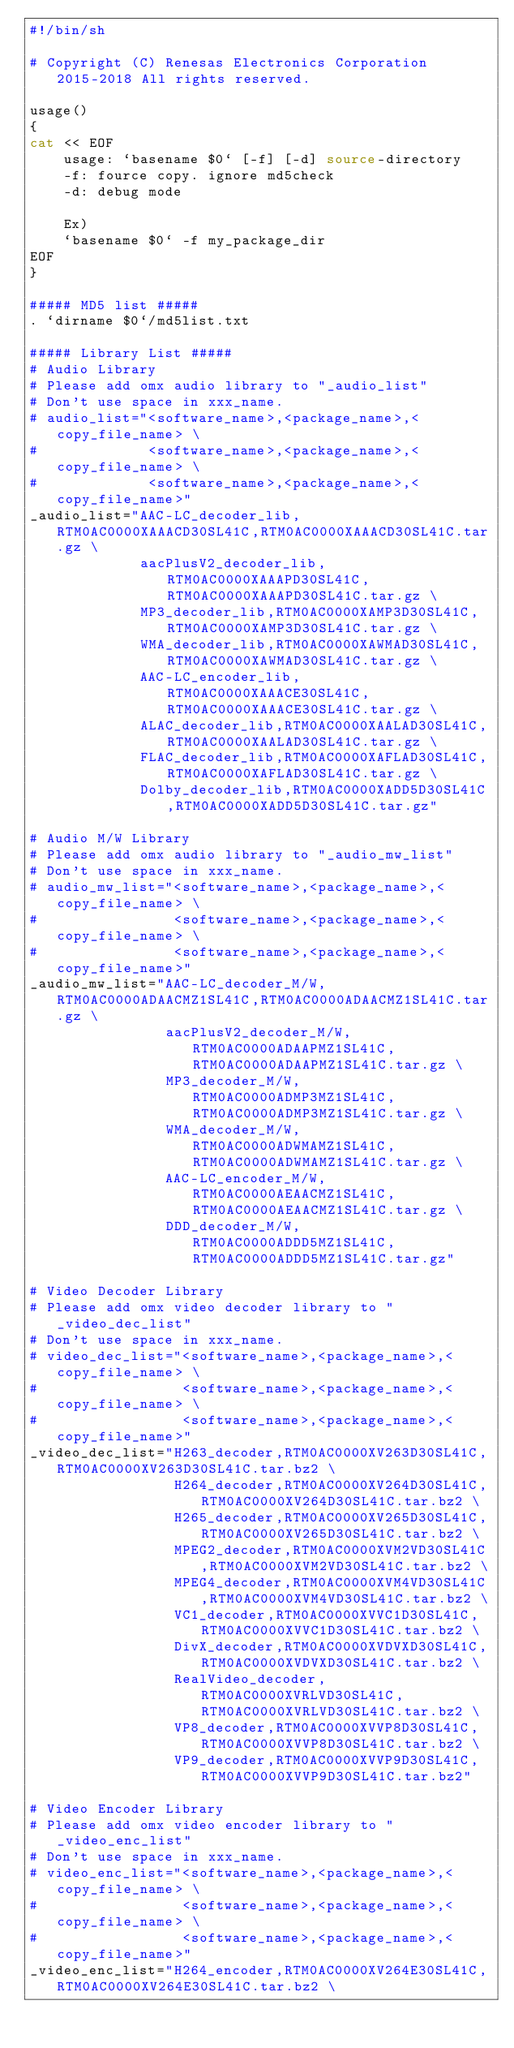<code> <loc_0><loc_0><loc_500><loc_500><_Bash_>#!/bin/sh

# Copyright (C) Renesas Electronics Corporation 2015-2018 All rights reserved.

usage()
{
cat << EOF
    usage: `basename $0` [-f] [-d] source-directory
    -f: fource copy. ignore md5check
    -d: debug mode

    Ex)
    `basename $0` -f my_package_dir
EOF
}

##### MD5 list #####
. `dirname $0`/md5list.txt

##### Library List #####
# Audio Library
# Please add omx audio library to "_audio_list"
# Don't use space in xxx_name.
# audio_list="<software_name>,<package_name>,<copy_file_name> \
#             <software_name>,<package_name>,<copy_file_name> \
#             <software_name>,<package_name>,<copy_file_name>"
_audio_list="AAC-LC_decoder_lib,RTM0AC0000XAAACD30SL41C,RTM0AC0000XAAACD30SL41C.tar.gz \
             aacPlusV2_decoder_lib,RTM0AC0000XAAAPD30SL41C,RTM0AC0000XAAAPD30SL41C.tar.gz \
             MP3_decoder_lib,RTM0AC0000XAMP3D30SL41C,RTM0AC0000XAMP3D30SL41C.tar.gz \
             WMA_decoder_lib,RTM0AC0000XAWMAD30SL41C,RTM0AC0000XAWMAD30SL41C.tar.gz \
             AAC-LC_encoder_lib,RTM0AC0000XAAACE30SL41C,RTM0AC0000XAAACE30SL41C.tar.gz \
             ALAC_decoder_lib,RTM0AC0000XAALAD30SL41C,RTM0AC0000XAALAD30SL41C.tar.gz \
             FLAC_decoder_lib,RTM0AC0000XAFLAD30SL41C,RTM0AC0000XAFLAD30SL41C.tar.gz \
             Dolby_decoder_lib,RTM0AC0000XADD5D30SL41C,RTM0AC0000XADD5D30SL41C.tar.gz"

# Audio M/W Library
# Please add omx audio library to "_audio_mw_list"
# Don't use space in xxx_name.
# audio_mw_list="<software_name>,<package_name>,<copy_file_name> \
#                <software_name>,<package_name>,<copy_file_name> \
#                <software_name>,<package_name>,<copy_file_name>"
_audio_mw_list="AAC-LC_decoder_M/W,RTM0AC0000ADAACMZ1SL41C,RTM0AC0000ADAACMZ1SL41C.tar.gz \
                aacPlusV2_decoder_M/W,RTM0AC0000ADAAPMZ1SL41C,RTM0AC0000ADAAPMZ1SL41C.tar.gz \
                MP3_decoder_M/W,RTM0AC0000ADMP3MZ1SL41C,RTM0AC0000ADMP3MZ1SL41C.tar.gz \
                WMA_decoder_M/W,RTM0AC0000ADWMAMZ1SL41C,RTM0AC0000ADWMAMZ1SL41C.tar.gz \
                AAC-LC_encoder_M/W,RTM0AC0000AEAACMZ1SL41C,RTM0AC0000AEAACMZ1SL41C.tar.gz \
                DDD_decoder_M/W,RTM0AC0000ADDD5MZ1SL41C,RTM0AC0000ADDD5MZ1SL41C.tar.gz"

# Video Decoder Library
# Please add omx video decoder library to "_video_dec_list"
# Don't use space in xxx_name.
# video_dec_list="<software_name>,<package_name>,<copy_file_name> \
#                 <software_name>,<package_name>,<copy_file_name> \
#                 <software_name>,<package_name>,<copy_file_name>"
_video_dec_list="H263_decoder,RTM0AC0000XV263D30SL41C,RTM0AC0000XV263D30SL41C.tar.bz2 \
                 H264_decoder,RTM0AC0000XV264D30SL41C,RTM0AC0000XV264D30SL41C.tar.bz2 \
                 H265_decoder,RTM0AC0000XV265D30SL41C,RTM0AC0000XV265D30SL41C.tar.bz2 \
                 MPEG2_decoder,RTM0AC0000XVM2VD30SL41C,RTM0AC0000XVM2VD30SL41C.tar.bz2 \
                 MPEG4_decoder,RTM0AC0000XVM4VD30SL41C,RTM0AC0000XVM4VD30SL41C.tar.bz2 \
                 VC1_decoder,RTM0AC0000XVVC1D30SL41C,RTM0AC0000XVVC1D30SL41C.tar.bz2 \
                 DivX_decoder,RTM0AC0000XVDVXD30SL41C,RTM0AC0000XVDVXD30SL41C.tar.bz2 \
                 RealVideo_decoder,RTM0AC0000XVRLVD30SL41C,RTM0AC0000XVRLVD30SL41C.tar.bz2 \
                 VP8_decoder,RTM0AC0000XVVP8D30SL41C,RTM0AC0000XVVP8D30SL41C.tar.bz2 \
                 VP9_decoder,RTM0AC0000XVVP9D30SL41C,RTM0AC0000XVVP9D30SL41C.tar.bz2"

# Video Encoder Library
# Please add omx video encoder library to "_video_enc_list"
# Don't use space in xxx_name.
# video_enc_list="<software_name>,<package_name>,<copy_file_name> \
#                 <software_name>,<package_name>,<copy_file_name> \
#                 <software_name>,<package_name>,<copy_file_name>"
_video_enc_list="H264_encoder,RTM0AC0000XV264E30SL41C,RTM0AC0000XV264E30SL41C.tar.bz2 \</code> 